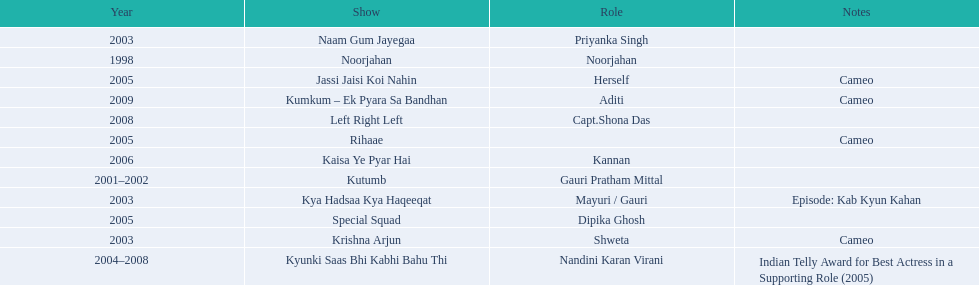What was the first tv series that gauri tejwani appeared in? Noorjahan. 